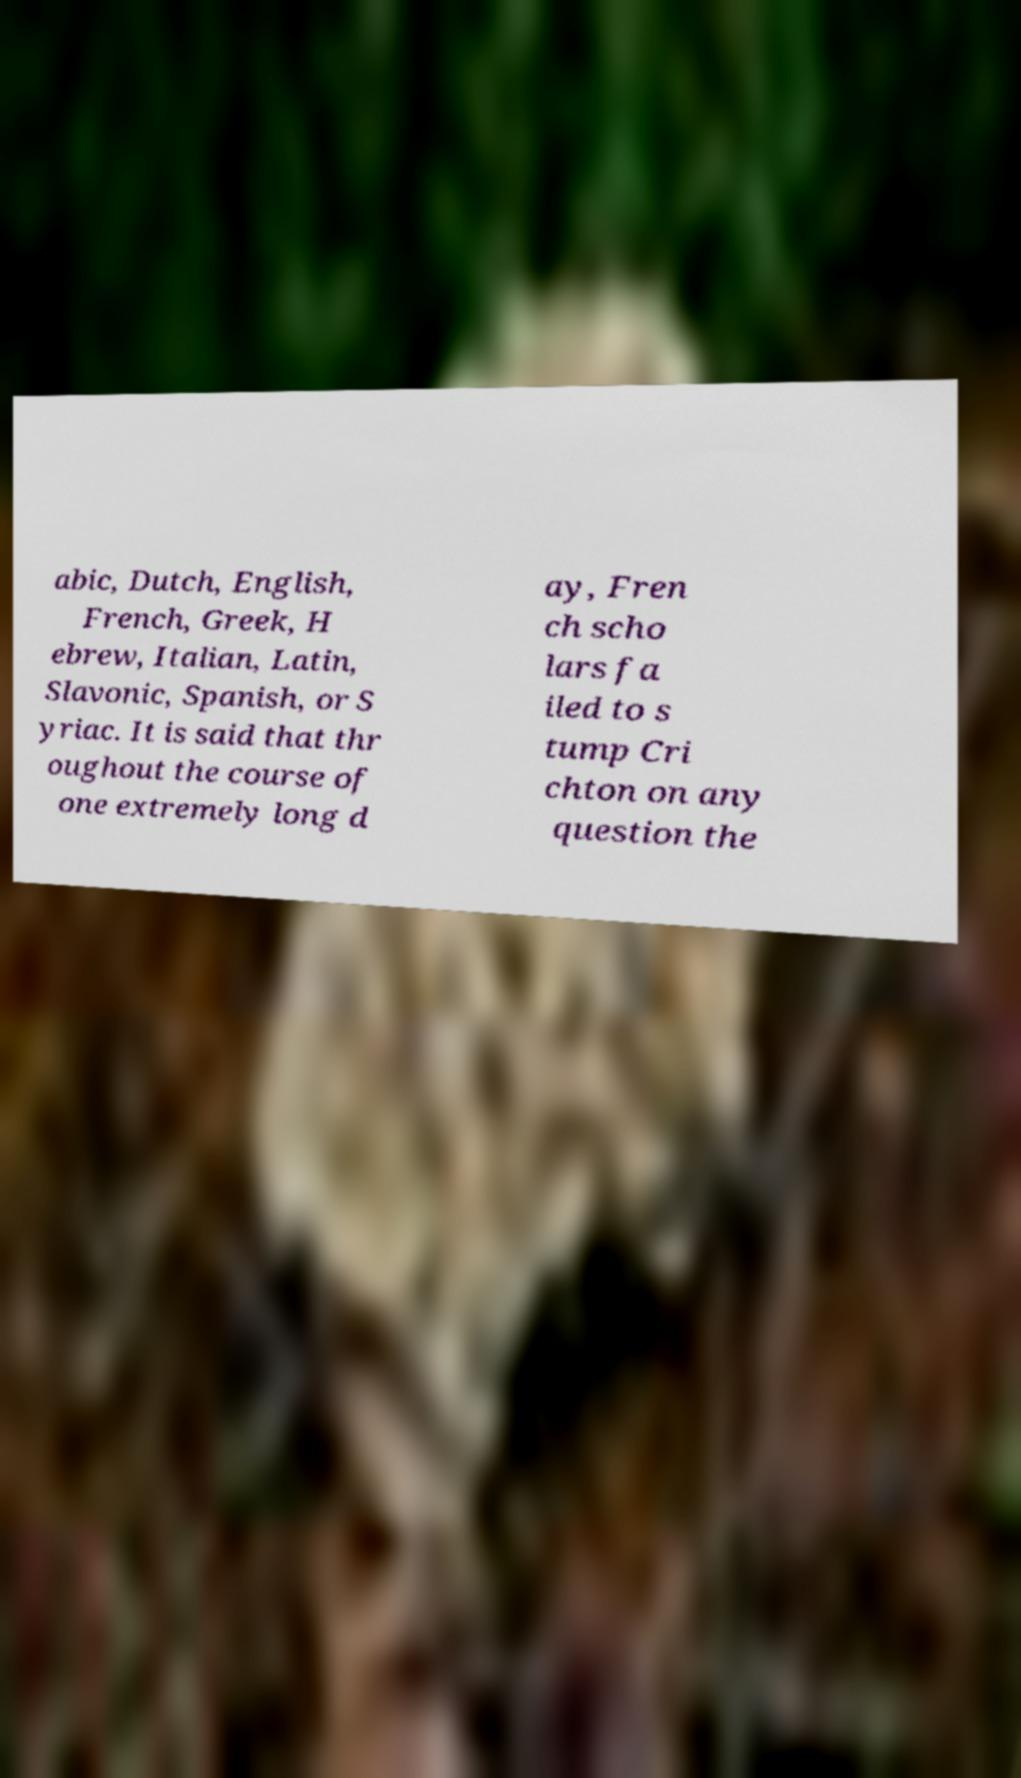There's text embedded in this image that I need extracted. Can you transcribe it verbatim? abic, Dutch, English, French, Greek, H ebrew, Italian, Latin, Slavonic, Spanish, or S yriac. It is said that thr oughout the course of one extremely long d ay, Fren ch scho lars fa iled to s tump Cri chton on any question the 